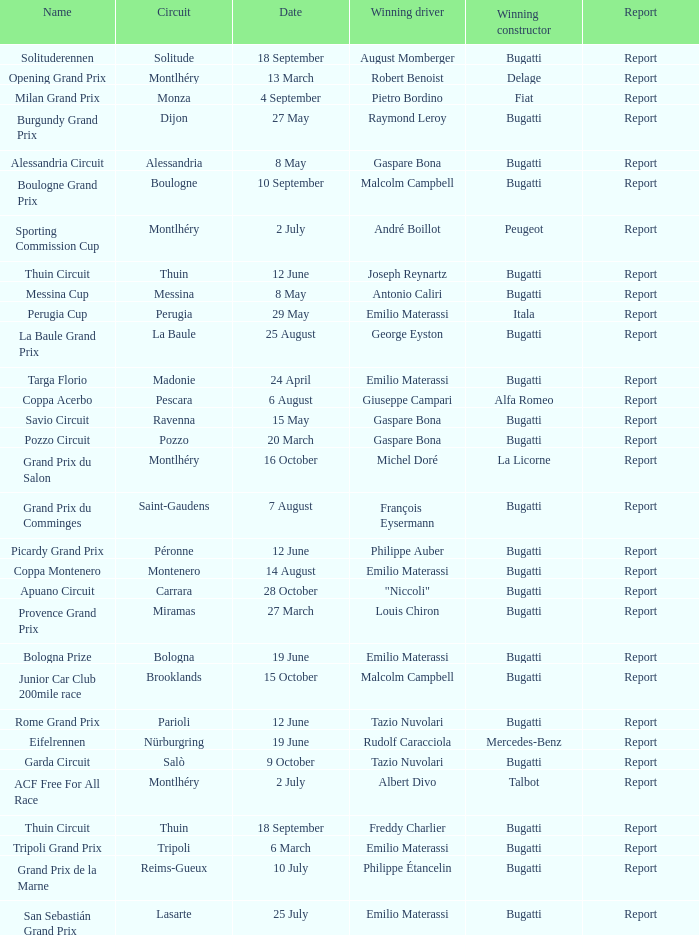Who was the winning constructor at the circuit of parioli? Bugatti. 